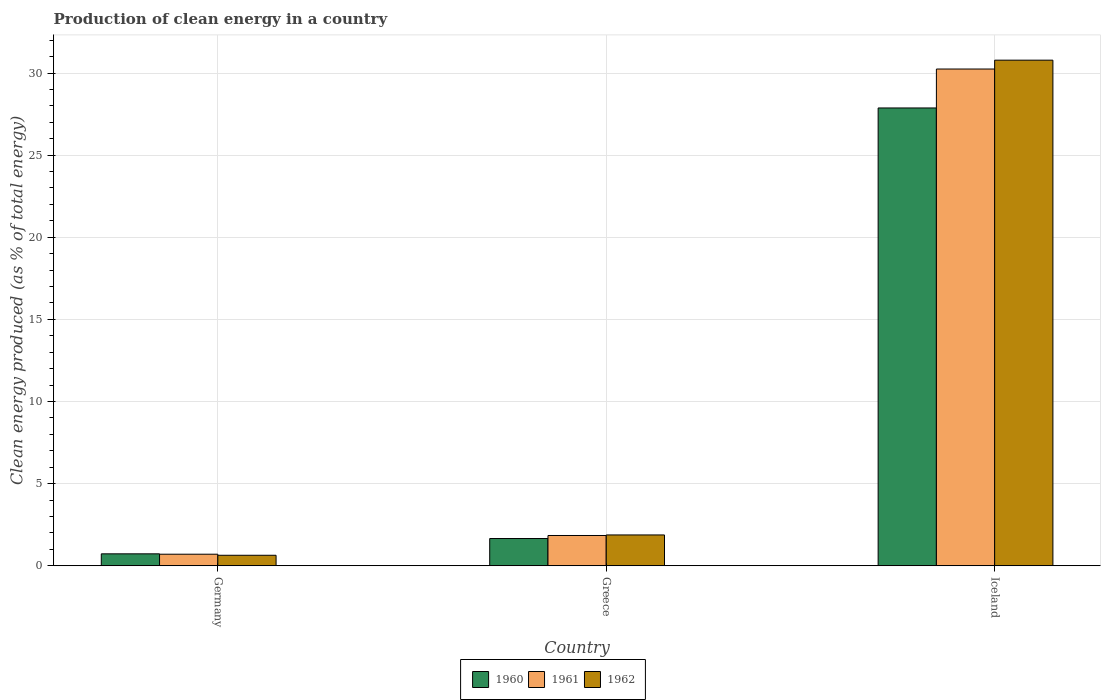Are the number of bars per tick equal to the number of legend labels?
Make the answer very short. Yes. How many bars are there on the 1st tick from the left?
Give a very brief answer. 3. What is the label of the 3rd group of bars from the left?
Make the answer very short. Iceland. What is the percentage of clean energy produced in 1960 in Iceland?
Offer a terse response. 27.87. Across all countries, what is the maximum percentage of clean energy produced in 1961?
Offer a very short reply. 30.24. Across all countries, what is the minimum percentage of clean energy produced in 1961?
Offer a very short reply. 0.7. What is the total percentage of clean energy produced in 1960 in the graph?
Provide a short and direct response. 30.26. What is the difference between the percentage of clean energy produced in 1962 in Germany and that in Iceland?
Make the answer very short. -30.14. What is the difference between the percentage of clean energy produced in 1962 in Greece and the percentage of clean energy produced in 1960 in Germany?
Make the answer very short. 1.15. What is the average percentage of clean energy produced in 1962 per country?
Make the answer very short. 11.1. What is the difference between the percentage of clean energy produced of/in 1962 and percentage of clean energy produced of/in 1960 in Greece?
Your answer should be compact. 0.22. In how many countries, is the percentage of clean energy produced in 1960 greater than 1 %?
Your answer should be very brief. 2. What is the ratio of the percentage of clean energy produced in 1960 in Greece to that in Iceland?
Give a very brief answer. 0.06. Is the difference between the percentage of clean energy produced in 1962 in Germany and Greece greater than the difference between the percentage of clean energy produced in 1960 in Germany and Greece?
Make the answer very short. No. What is the difference between the highest and the second highest percentage of clean energy produced in 1962?
Offer a very short reply. -1.24. What is the difference between the highest and the lowest percentage of clean energy produced in 1961?
Provide a short and direct response. 29.54. Are all the bars in the graph horizontal?
Your answer should be very brief. No. Are the values on the major ticks of Y-axis written in scientific E-notation?
Your answer should be very brief. No. Does the graph contain any zero values?
Your answer should be compact. No. What is the title of the graph?
Make the answer very short. Production of clean energy in a country. Does "1976" appear as one of the legend labels in the graph?
Your response must be concise. No. What is the label or title of the Y-axis?
Provide a short and direct response. Clean energy produced (as % of total energy). What is the Clean energy produced (as % of total energy) in 1960 in Germany?
Ensure brevity in your answer.  0.73. What is the Clean energy produced (as % of total energy) in 1961 in Germany?
Provide a succinct answer. 0.7. What is the Clean energy produced (as % of total energy) in 1962 in Germany?
Your response must be concise. 0.64. What is the Clean energy produced (as % of total energy) of 1960 in Greece?
Your answer should be very brief. 1.66. What is the Clean energy produced (as % of total energy) in 1961 in Greece?
Provide a short and direct response. 1.84. What is the Clean energy produced (as % of total energy) in 1962 in Greece?
Provide a short and direct response. 1.88. What is the Clean energy produced (as % of total energy) of 1960 in Iceland?
Make the answer very short. 27.87. What is the Clean energy produced (as % of total energy) of 1961 in Iceland?
Your response must be concise. 30.24. What is the Clean energy produced (as % of total energy) of 1962 in Iceland?
Offer a terse response. 30.78. Across all countries, what is the maximum Clean energy produced (as % of total energy) of 1960?
Provide a short and direct response. 27.87. Across all countries, what is the maximum Clean energy produced (as % of total energy) of 1961?
Make the answer very short. 30.24. Across all countries, what is the maximum Clean energy produced (as % of total energy) of 1962?
Offer a terse response. 30.78. Across all countries, what is the minimum Clean energy produced (as % of total energy) in 1960?
Ensure brevity in your answer.  0.73. Across all countries, what is the minimum Clean energy produced (as % of total energy) in 1961?
Provide a succinct answer. 0.7. Across all countries, what is the minimum Clean energy produced (as % of total energy) of 1962?
Provide a short and direct response. 0.64. What is the total Clean energy produced (as % of total energy) of 1960 in the graph?
Provide a succinct answer. 30.26. What is the total Clean energy produced (as % of total energy) of 1961 in the graph?
Ensure brevity in your answer.  32.79. What is the total Clean energy produced (as % of total energy) in 1962 in the graph?
Provide a succinct answer. 33.3. What is the difference between the Clean energy produced (as % of total energy) in 1960 in Germany and that in Greece?
Your response must be concise. -0.93. What is the difference between the Clean energy produced (as % of total energy) of 1961 in Germany and that in Greece?
Give a very brief answer. -1.14. What is the difference between the Clean energy produced (as % of total energy) of 1962 in Germany and that in Greece?
Offer a terse response. -1.24. What is the difference between the Clean energy produced (as % of total energy) of 1960 in Germany and that in Iceland?
Provide a succinct answer. -27.14. What is the difference between the Clean energy produced (as % of total energy) in 1961 in Germany and that in Iceland?
Make the answer very short. -29.54. What is the difference between the Clean energy produced (as % of total energy) in 1962 in Germany and that in Iceland?
Offer a very short reply. -30.14. What is the difference between the Clean energy produced (as % of total energy) in 1960 in Greece and that in Iceland?
Offer a terse response. -26.21. What is the difference between the Clean energy produced (as % of total energy) of 1961 in Greece and that in Iceland?
Your answer should be compact. -28.4. What is the difference between the Clean energy produced (as % of total energy) of 1962 in Greece and that in Iceland?
Your answer should be very brief. -28.9. What is the difference between the Clean energy produced (as % of total energy) of 1960 in Germany and the Clean energy produced (as % of total energy) of 1961 in Greece?
Provide a succinct answer. -1.12. What is the difference between the Clean energy produced (as % of total energy) in 1960 in Germany and the Clean energy produced (as % of total energy) in 1962 in Greece?
Ensure brevity in your answer.  -1.15. What is the difference between the Clean energy produced (as % of total energy) of 1961 in Germany and the Clean energy produced (as % of total energy) of 1962 in Greece?
Provide a succinct answer. -1.17. What is the difference between the Clean energy produced (as % of total energy) of 1960 in Germany and the Clean energy produced (as % of total energy) of 1961 in Iceland?
Your answer should be very brief. -29.52. What is the difference between the Clean energy produced (as % of total energy) in 1960 in Germany and the Clean energy produced (as % of total energy) in 1962 in Iceland?
Give a very brief answer. -30.05. What is the difference between the Clean energy produced (as % of total energy) in 1961 in Germany and the Clean energy produced (as % of total energy) in 1962 in Iceland?
Your answer should be compact. -30.08. What is the difference between the Clean energy produced (as % of total energy) in 1960 in Greece and the Clean energy produced (as % of total energy) in 1961 in Iceland?
Provide a short and direct response. -28.58. What is the difference between the Clean energy produced (as % of total energy) in 1960 in Greece and the Clean energy produced (as % of total energy) in 1962 in Iceland?
Offer a very short reply. -29.12. What is the difference between the Clean energy produced (as % of total energy) of 1961 in Greece and the Clean energy produced (as % of total energy) of 1962 in Iceland?
Make the answer very short. -28.94. What is the average Clean energy produced (as % of total energy) in 1960 per country?
Your answer should be compact. 10.09. What is the average Clean energy produced (as % of total energy) of 1961 per country?
Offer a terse response. 10.93. What is the average Clean energy produced (as % of total energy) in 1962 per country?
Your answer should be compact. 11.1. What is the difference between the Clean energy produced (as % of total energy) in 1960 and Clean energy produced (as % of total energy) in 1961 in Germany?
Your answer should be very brief. 0.02. What is the difference between the Clean energy produced (as % of total energy) of 1960 and Clean energy produced (as % of total energy) of 1962 in Germany?
Ensure brevity in your answer.  0.09. What is the difference between the Clean energy produced (as % of total energy) of 1961 and Clean energy produced (as % of total energy) of 1962 in Germany?
Make the answer very short. 0.06. What is the difference between the Clean energy produced (as % of total energy) of 1960 and Clean energy produced (as % of total energy) of 1961 in Greece?
Keep it short and to the point. -0.18. What is the difference between the Clean energy produced (as % of total energy) in 1960 and Clean energy produced (as % of total energy) in 1962 in Greece?
Your response must be concise. -0.22. What is the difference between the Clean energy produced (as % of total energy) of 1961 and Clean energy produced (as % of total energy) of 1962 in Greece?
Your answer should be compact. -0.03. What is the difference between the Clean energy produced (as % of total energy) of 1960 and Clean energy produced (as % of total energy) of 1961 in Iceland?
Your response must be concise. -2.37. What is the difference between the Clean energy produced (as % of total energy) of 1960 and Clean energy produced (as % of total energy) of 1962 in Iceland?
Your answer should be very brief. -2.91. What is the difference between the Clean energy produced (as % of total energy) of 1961 and Clean energy produced (as % of total energy) of 1962 in Iceland?
Your answer should be very brief. -0.54. What is the ratio of the Clean energy produced (as % of total energy) in 1960 in Germany to that in Greece?
Ensure brevity in your answer.  0.44. What is the ratio of the Clean energy produced (as % of total energy) of 1961 in Germany to that in Greece?
Ensure brevity in your answer.  0.38. What is the ratio of the Clean energy produced (as % of total energy) of 1962 in Germany to that in Greece?
Keep it short and to the point. 0.34. What is the ratio of the Clean energy produced (as % of total energy) in 1960 in Germany to that in Iceland?
Make the answer very short. 0.03. What is the ratio of the Clean energy produced (as % of total energy) in 1961 in Germany to that in Iceland?
Provide a short and direct response. 0.02. What is the ratio of the Clean energy produced (as % of total energy) in 1962 in Germany to that in Iceland?
Offer a terse response. 0.02. What is the ratio of the Clean energy produced (as % of total energy) of 1960 in Greece to that in Iceland?
Your answer should be very brief. 0.06. What is the ratio of the Clean energy produced (as % of total energy) in 1961 in Greece to that in Iceland?
Provide a succinct answer. 0.06. What is the ratio of the Clean energy produced (as % of total energy) of 1962 in Greece to that in Iceland?
Make the answer very short. 0.06. What is the difference between the highest and the second highest Clean energy produced (as % of total energy) in 1960?
Your response must be concise. 26.21. What is the difference between the highest and the second highest Clean energy produced (as % of total energy) in 1961?
Provide a succinct answer. 28.4. What is the difference between the highest and the second highest Clean energy produced (as % of total energy) of 1962?
Provide a short and direct response. 28.9. What is the difference between the highest and the lowest Clean energy produced (as % of total energy) in 1960?
Provide a short and direct response. 27.14. What is the difference between the highest and the lowest Clean energy produced (as % of total energy) in 1961?
Provide a short and direct response. 29.54. What is the difference between the highest and the lowest Clean energy produced (as % of total energy) in 1962?
Make the answer very short. 30.14. 